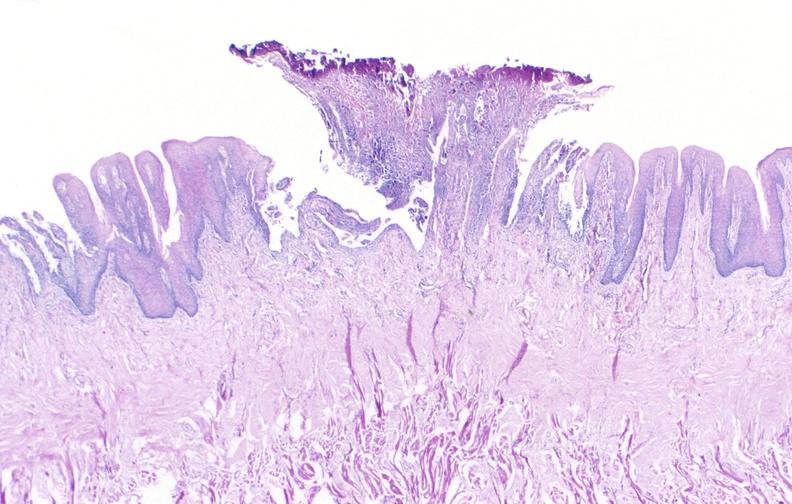where is this from?
Answer the question using a single word or phrase. Gastrointestinal system 